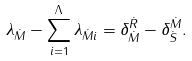Convert formula to latex. <formula><loc_0><loc_0><loc_500><loc_500>\lambda _ { \dot { M } } - \sum _ { i = 1 } ^ { \Lambda } \lambda _ { \dot { M } i } = \delta ^ { \dot { R } } _ { \dot { M } } - \delta ^ { \dot { M } } _ { \dot { S } } .</formula> 